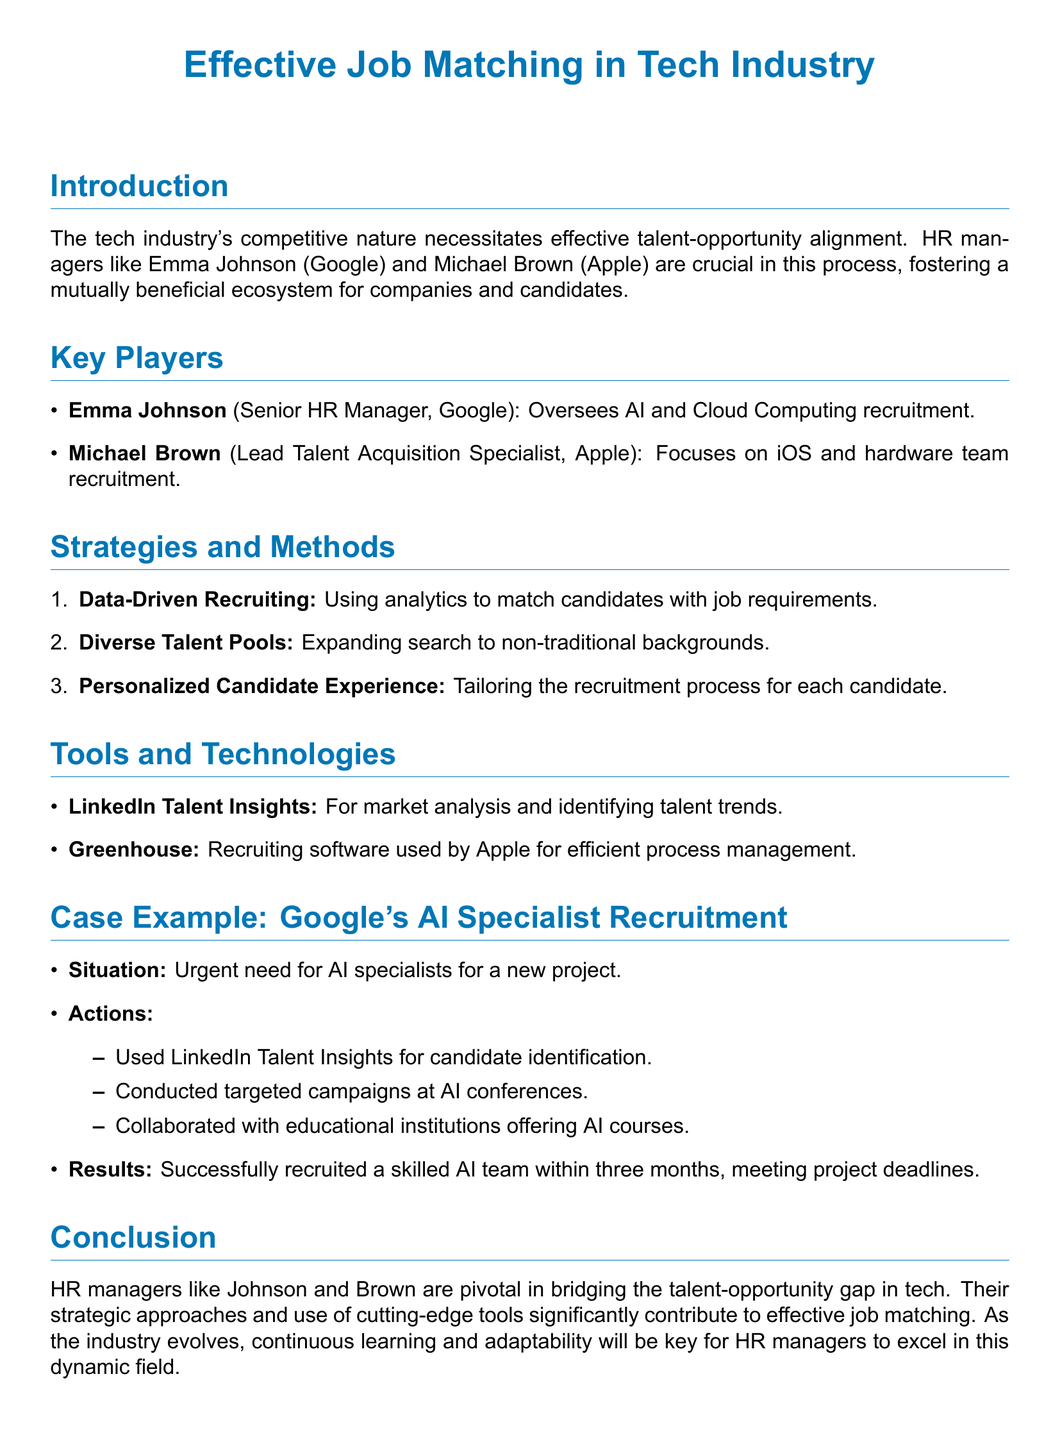What is the name of the HR manager at Google? The document states that the HR manager at Google is Emma Johnson.
Answer: Emma Johnson What recruitment area does Michael Brown specialize in? According to the document, Michael Brown focuses on iOS and hardware team recruitment.
Answer: iOS and hardware team recruitment What tool is used by Apple for efficient process management? The document mentions that Apple uses Greenhouse as their recruiting software for efficient process management.
Answer: Greenhouse How many months did it take Google to recruit the AI team? The document indicates that Google successfully recruited a skilled AI team within three months.
Answer: three months What strategy involves using analytics to match candidates with job requirements? The document refers to this strategy as Data-Driven Recruiting.
Answer: Data-Driven Recruiting Which specific event did Google conduct targeted campaigns at for recruitment? The document specifies that Google conducted targeted campaigns at AI conferences.
Answer: AI conferences What is a key responsibility of HR managers in the tech industry? The document highlights that HR managers are crucial in bridging the talent-opportunity gap in tech.
Answer: bridging the talent-opportunity gap What color is used for section titles in the document? The document mentions that the section titles are colored tech blue, specifically defined in the colors section.
Answer: tech blue 